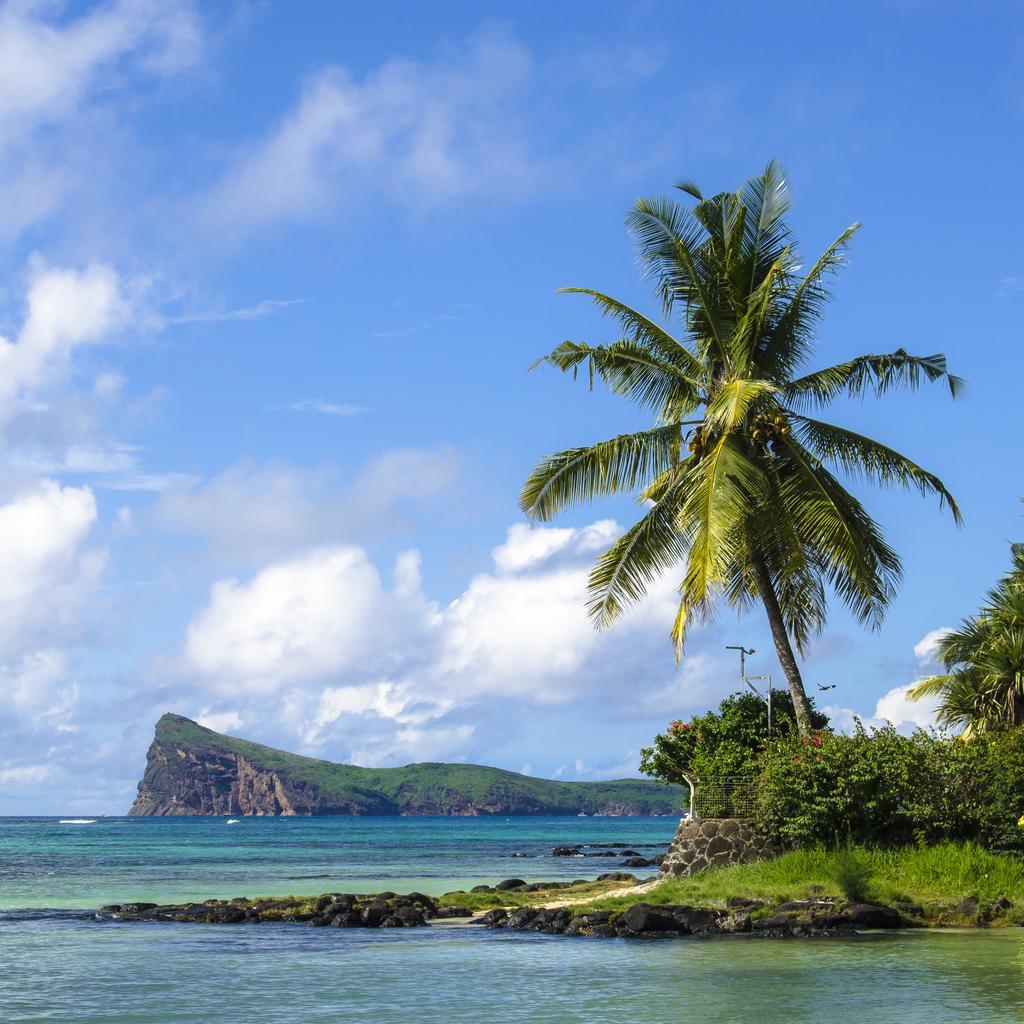Can you describe this image briefly? In this image I can see the water, some grass on the ground, few plants and few trees which are green in color. In the background I can see a mountain and the sky. 